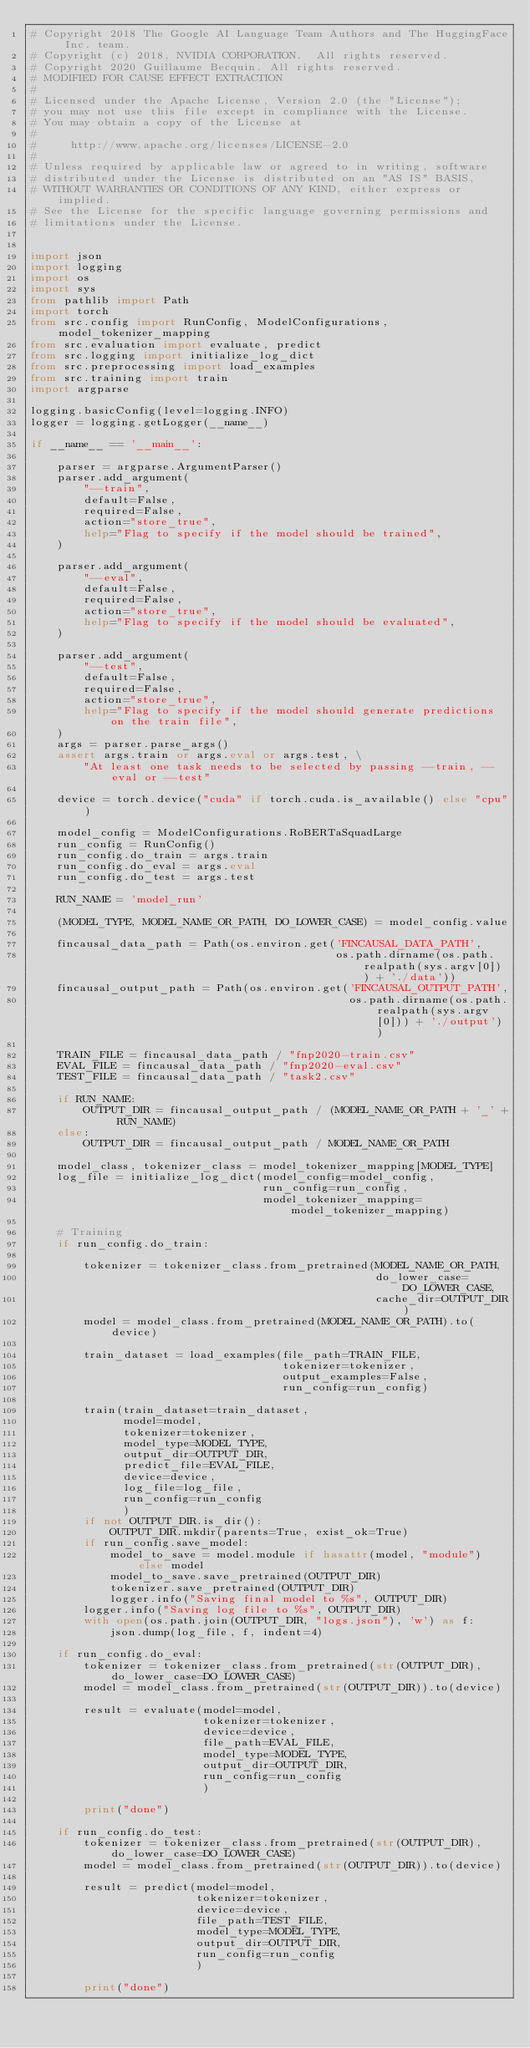Convert code to text. <code><loc_0><loc_0><loc_500><loc_500><_Python_># Copyright 2018 The Google AI Language Team Authors and The HuggingFace Inc. team.
# Copyright (c) 2018, NVIDIA CORPORATION.  All rights reserved.
# Copyright 2020 Guillaume Becquin. All rights reserved.
# MODIFIED FOR CAUSE EFFECT EXTRACTION
#
# Licensed under the Apache License, Version 2.0 (the "License");
# you may not use this file except in compliance with the License.
# You may obtain a copy of the License at
#
#     http://www.apache.org/licenses/LICENSE-2.0
#
# Unless required by applicable law or agreed to in writing, software
# distributed under the License is distributed on an "AS IS" BASIS,
# WITHOUT WARRANTIES OR CONDITIONS OF ANY KIND, either express or implied.
# See the License for the specific language governing permissions and
# limitations under the License.


import json
import logging
import os
import sys
from pathlib import Path
import torch
from src.config import RunConfig, ModelConfigurations, model_tokenizer_mapping
from src.evaluation import evaluate, predict
from src.logging import initialize_log_dict
from src.preprocessing import load_examples
from src.training import train
import argparse

logging.basicConfig(level=logging.INFO)
logger = logging.getLogger(__name__)

if __name__ == '__main__':

    parser = argparse.ArgumentParser()
    parser.add_argument(
        "--train",
        default=False,
        required=False,
        action="store_true",
        help="Flag to specify if the model should be trained",
    )

    parser.add_argument(
        "--eval",
        default=False,
        required=False,
        action="store_true",
        help="Flag to specify if the model should be evaluated",
    )

    parser.add_argument(
        "--test",
        default=False,
        required=False,
        action="store_true",
        help="Flag to specify if the model should generate predictions on the train file",
    )
    args = parser.parse_args()
    assert args.train or args.eval or args.test, \
        "At least one task needs to be selected by passing --train, --eval or --test"

    device = torch.device("cuda" if torch.cuda.is_available() else "cpu")

    model_config = ModelConfigurations.RoBERTaSquadLarge
    run_config = RunConfig()
    run_config.do_train = args.train
    run_config.do_eval = args.eval
    run_config.do_test = args.test

    RUN_NAME = 'model_run'

    (MODEL_TYPE, MODEL_NAME_OR_PATH, DO_LOWER_CASE) = model_config.value

    fincausal_data_path = Path(os.environ.get('FINCAUSAL_DATA_PATH',
                                              os.path.dirname(os.path.realpath(sys.argv[0])) + './data'))
    fincausal_output_path = Path(os.environ.get('FINCAUSAL_OUTPUT_PATH',
                                                os.path.dirname(os.path.realpath(sys.argv[0])) + './output'))

    TRAIN_FILE = fincausal_data_path / "fnp2020-train.csv"
    EVAL_FILE = fincausal_data_path / "fnp2020-eval.csv"
    TEST_FILE = fincausal_data_path / "task2.csv"

    if RUN_NAME:
        OUTPUT_DIR = fincausal_output_path / (MODEL_NAME_OR_PATH + '_' + RUN_NAME)
    else:
        OUTPUT_DIR = fincausal_output_path / MODEL_NAME_OR_PATH

    model_class, tokenizer_class = model_tokenizer_mapping[MODEL_TYPE]
    log_file = initialize_log_dict(model_config=model_config,
                                   run_config=run_config,
                                   model_tokenizer_mapping=model_tokenizer_mapping)

    # Training
    if run_config.do_train:

        tokenizer = tokenizer_class.from_pretrained(MODEL_NAME_OR_PATH,
                                                    do_lower_case=DO_LOWER_CASE,
                                                    cache_dir=OUTPUT_DIR)
        model = model_class.from_pretrained(MODEL_NAME_OR_PATH).to(device)

        train_dataset = load_examples(file_path=TRAIN_FILE,
                                      tokenizer=tokenizer,
                                      output_examples=False,
                                      run_config=run_config)

        train(train_dataset=train_dataset,
              model=model,
              tokenizer=tokenizer,
              model_type=MODEL_TYPE,
              output_dir=OUTPUT_DIR,
              predict_file=EVAL_FILE,
              device=device,
              log_file=log_file,
              run_config=run_config
              )
        if not OUTPUT_DIR.is_dir():
            OUTPUT_DIR.mkdir(parents=True, exist_ok=True)
        if run_config.save_model:
            model_to_save = model.module if hasattr(model, "module") else model
            model_to_save.save_pretrained(OUTPUT_DIR)
            tokenizer.save_pretrained(OUTPUT_DIR)
            logger.info("Saving final model to %s", OUTPUT_DIR)
        logger.info("Saving log file to %s", OUTPUT_DIR)
        with open(os.path.join(OUTPUT_DIR, "logs.json"), 'w') as f:
            json.dump(log_file, f, indent=4)

    if run_config.do_eval:
        tokenizer = tokenizer_class.from_pretrained(str(OUTPUT_DIR), do_lower_case=DO_LOWER_CASE)
        model = model_class.from_pretrained(str(OUTPUT_DIR)).to(device)

        result = evaluate(model=model,
                          tokenizer=tokenizer,
                          device=device,
                          file_path=EVAL_FILE,
                          model_type=MODEL_TYPE,
                          output_dir=OUTPUT_DIR,
                          run_config=run_config
                          )

        print("done")

    if run_config.do_test:
        tokenizer = tokenizer_class.from_pretrained(str(OUTPUT_DIR), do_lower_case=DO_LOWER_CASE)
        model = model_class.from_pretrained(str(OUTPUT_DIR)).to(device)

        result = predict(model=model,
                         tokenizer=tokenizer,
                         device=device,
                         file_path=TEST_FILE,
                         model_type=MODEL_TYPE,
                         output_dir=OUTPUT_DIR,
                         run_config=run_config
                         )

        print("done")
</code> 